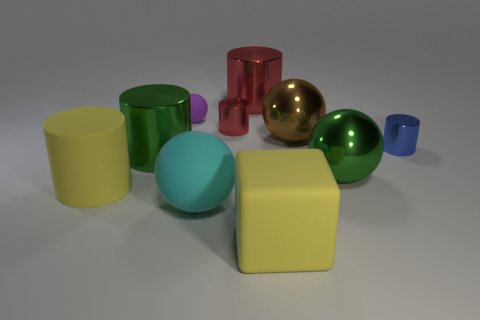Subtract 2 cylinders. How many cylinders are left? 3 Subtract all brown balls. How many balls are left? 3 Subtract all brown metal spheres. How many spheres are left? 3 Subtract all yellow balls. Subtract all purple cylinders. How many balls are left? 4 Subtract all cubes. How many objects are left? 9 Add 3 blue metallic cylinders. How many blue metallic cylinders are left? 4 Add 8 rubber cylinders. How many rubber cylinders exist? 9 Subtract 1 red cylinders. How many objects are left? 9 Subtract all green objects. Subtract all large brown things. How many objects are left? 7 